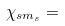<formula> <loc_0><loc_0><loc_500><loc_500>\chi _ { s m _ { s } } =</formula> 